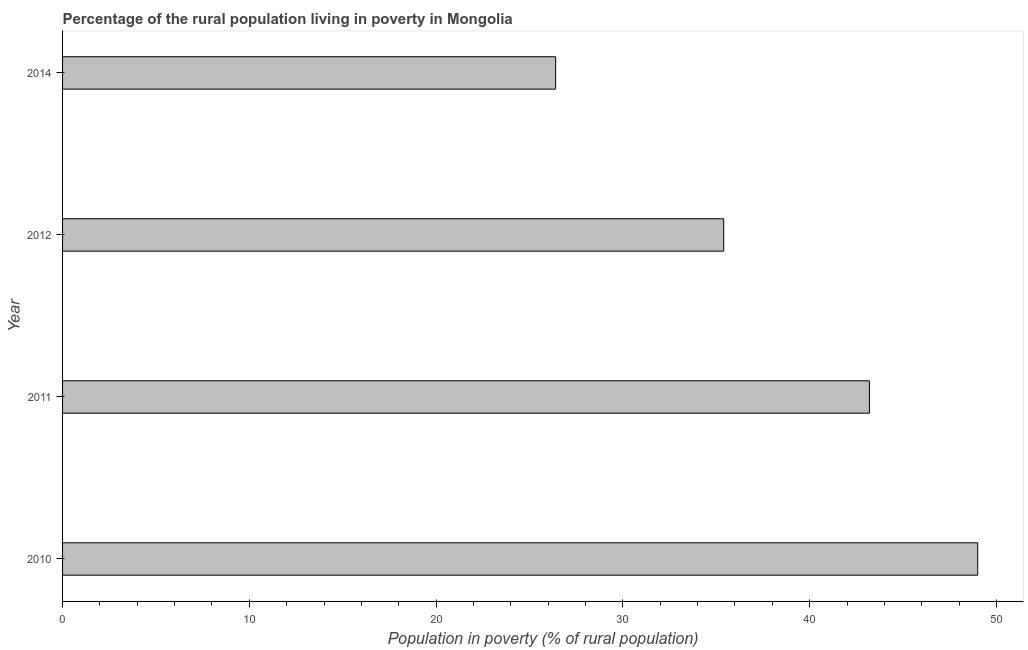Does the graph contain any zero values?
Offer a very short reply. No. What is the title of the graph?
Offer a very short reply. Percentage of the rural population living in poverty in Mongolia. What is the label or title of the X-axis?
Provide a succinct answer. Population in poverty (% of rural population). What is the label or title of the Y-axis?
Your answer should be compact. Year. What is the percentage of rural population living below poverty line in 2014?
Give a very brief answer. 26.4. Across all years, what is the maximum percentage of rural population living below poverty line?
Offer a very short reply. 49. Across all years, what is the minimum percentage of rural population living below poverty line?
Offer a very short reply. 26.4. In which year was the percentage of rural population living below poverty line maximum?
Your answer should be very brief. 2010. In which year was the percentage of rural population living below poverty line minimum?
Your answer should be compact. 2014. What is the sum of the percentage of rural population living below poverty line?
Your answer should be compact. 154. What is the difference between the percentage of rural population living below poverty line in 2011 and 2012?
Make the answer very short. 7.8. What is the average percentage of rural population living below poverty line per year?
Provide a short and direct response. 38.5. What is the median percentage of rural population living below poverty line?
Give a very brief answer. 39.3. In how many years, is the percentage of rural population living below poverty line greater than 16 %?
Give a very brief answer. 4. Do a majority of the years between 2014 and 2011 (inclusive) have percentage of rural population living below poverty line greater than 2 %?
Make the answer very short. Yes. What is the ratio of the percentage of rural population living below poverty line in 2011 to that in 2014?
Offer a terse response. 1.64. Is the percentage of rural population living below poverty line in 2011 less than that in 2014?
Your answer should be compact. No. What is the difference between the highest and the lowest percentage of rural population living below poverty line?
Your answer should be compact. 22.6. How many bars are there?
Offer a terse response. 4. What is the Population in poverty (% of rural population) of 2011?
Your answer should be compact. 43.2. What is the Population in poverty (% of rural population) of 2012?
Offer a terse response. 35.4. What is the Population in poverty (% of rural population) of 2014?
Provide a short and direct response. 26.4. What is the difference between the Population in poverty (% of rural population) in 2010 and 2014?
Provide a short and direct response. 22.6. What is the difference between the Population in poverty (% of rural population) in 2011 and 2012?
Ensure brevity in your answer.  7.8. What is the difference between the Population in poverty (% of rural population) in 2012 and 2014?
Your answer should be compact. 9. What is the ratio of the Population in poverty (% of rural population) in 2010 to that in 2011?
Your response must be concise. 1.13. What is the ratio of the Population in poverty (% of rural population) in 2010 to that in 2012?
Keep it short and to the point. 1.38. What is the ratio of the Population in poverty (% of rural population) in 2010 to that in 2014?
Keep it short and to the point. 1.86. What is the ratio of the Population in poverty (% of rural population) in 2011 to that in 2012?
Ensure brevity in your answer.  1.22. What is the ratio of the Population in poverty (% of rural population) in 2011 to that in 2014?
Offer a very short reply. 1.64. What is the ratio of the Population in poverty (% of rural population) in 2012 to that in 2014?
Offer a terse response. 1.34. 